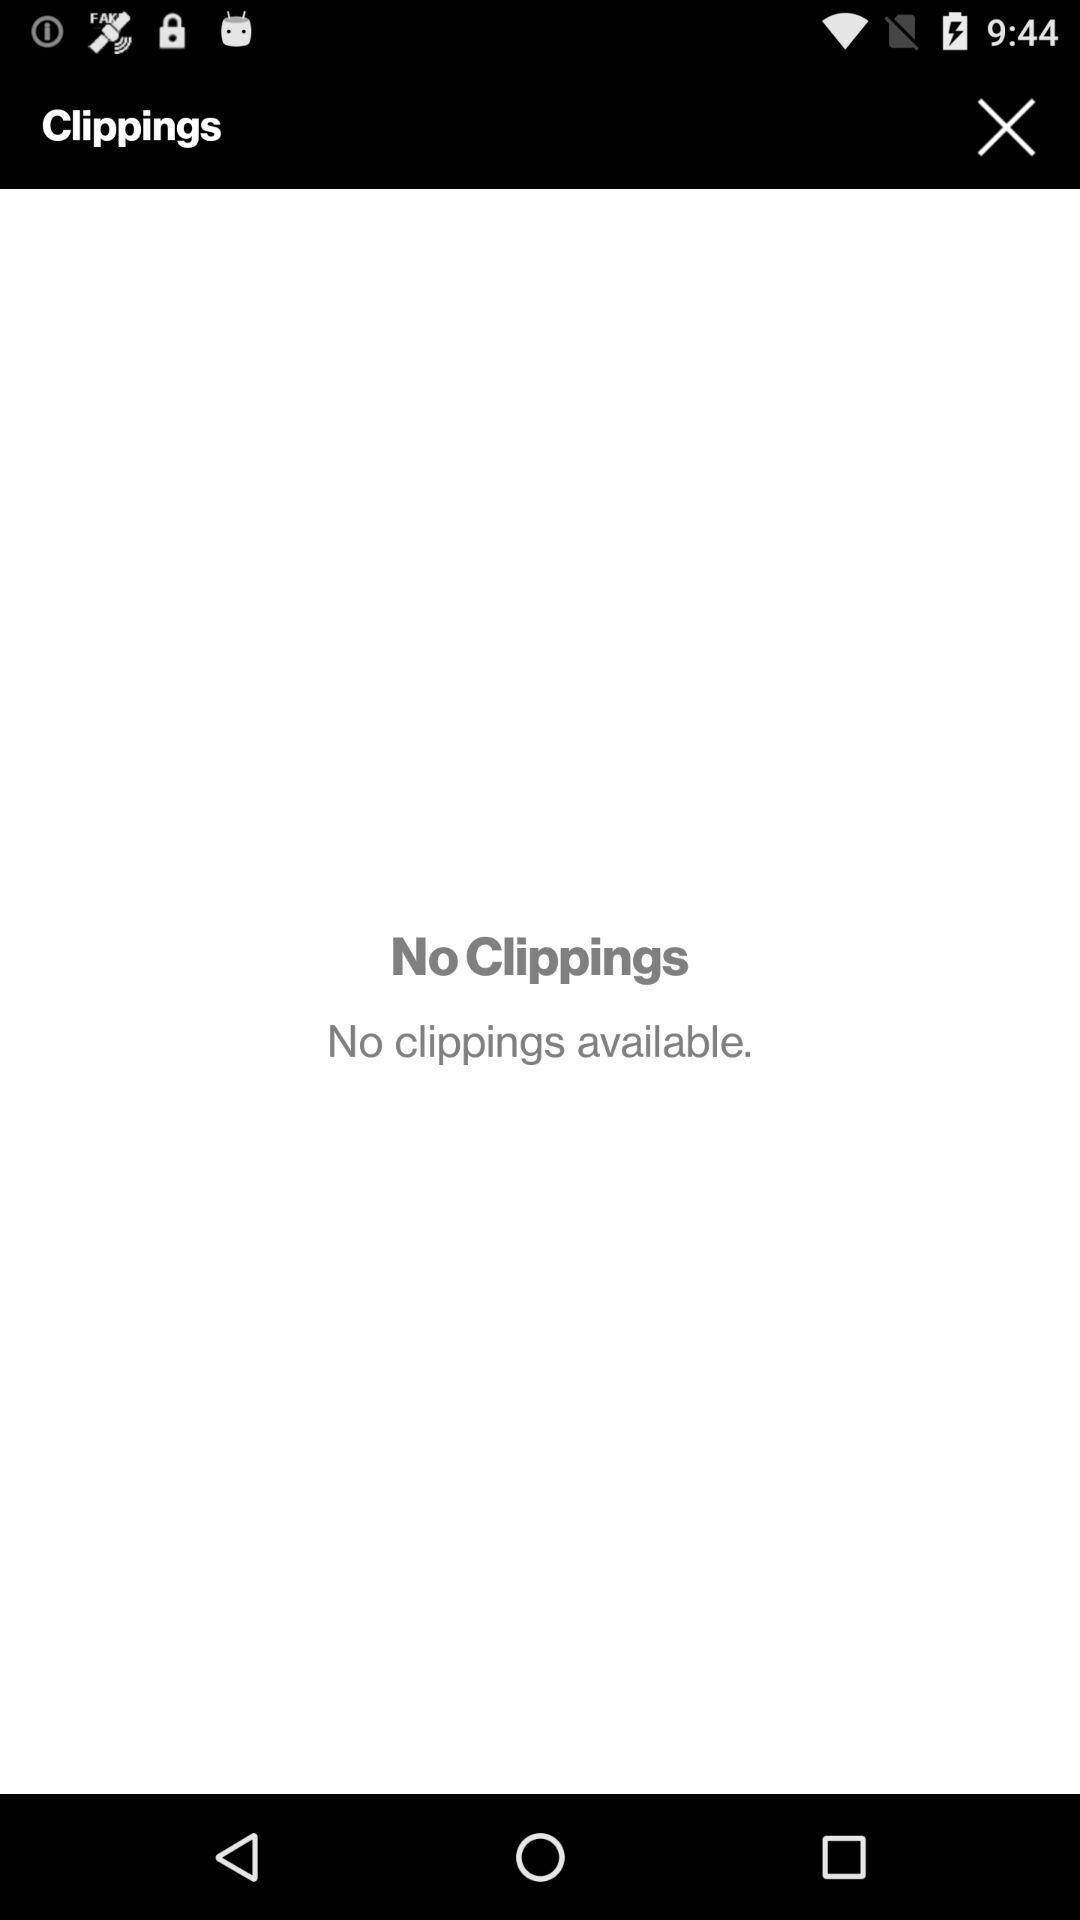Is there any clipping available? There are no clippings available. 